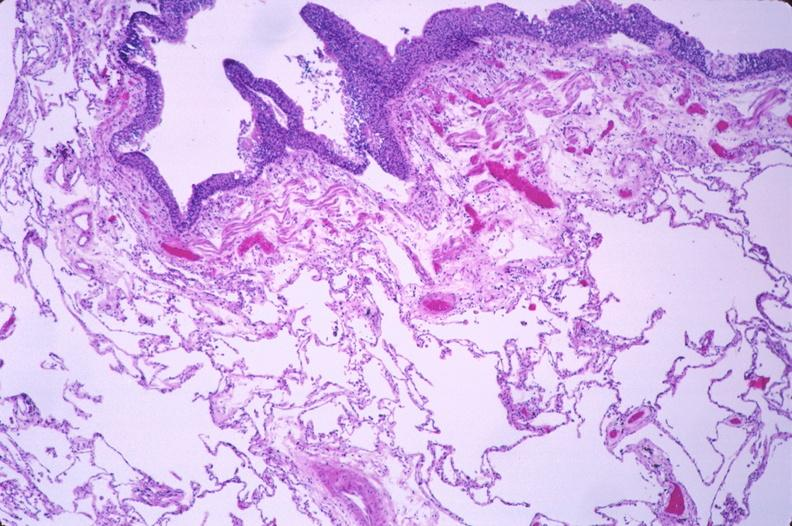does this image show lung, squamous metaplasia of bronchus in a chronic smoker?
Answer the question using a single word or phrase. Yes 